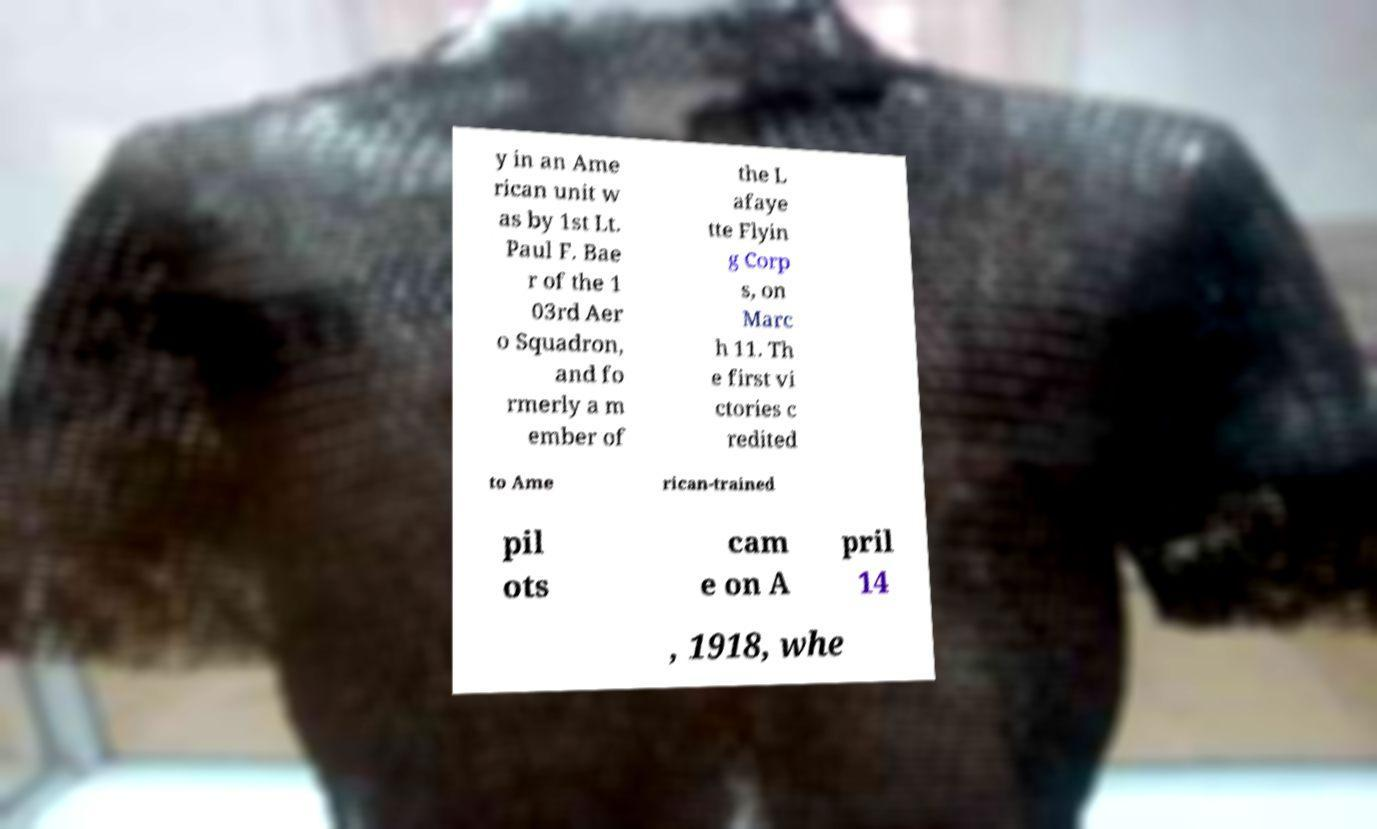Could you assist in decoding the text presented in this image and type it out clearly? y in an Ame rican unit w as by 1st Lt. Paul F. Bae r of the 1 03rd Aer o Squadron, and fo rmerly a m ember of the L afaye tte Flyin g Corp s, on Marc h 11. Th e first vi ctories c redited to Ame rican-trained pil ots cam e on A pril 14 , 1918, whe 